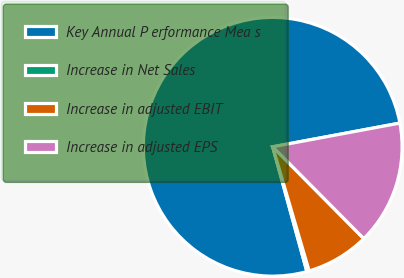Convert chart. <chart><loc_0><loc_0><loc_500><loc_500><pie_chart><fcel>Key Annual P erformance Mea s<fcel>Increase in Net Sales<fcel>Increase in adjusted EBIT<fcel>Increase in adjusted EPS<nl><fcel>76.32%<fcel>0.29%<fcel>7.89%<fcel>15.5%<nl></chart> 